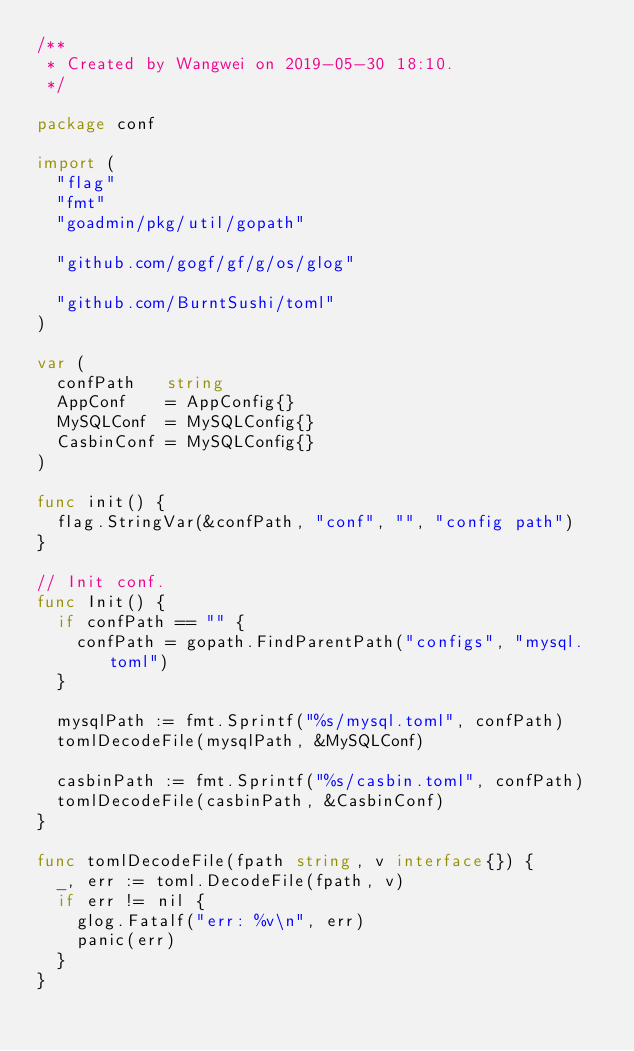<code> <loc_0><loc_0><loc_500><loc_500><_Go_>/**
 * Created by Wangwei on 2019-05-30 18:10.
 */

package conf

import (
	"flag"
	"fmt"
	"goadmin/pkg/util/gopath"

	"github.com/gogf/gf/g/os/glog"

	"github.com/BurntSushi/toml"
)

var (
	confPath   string
	AppConf    = AppConfig{}
	MySQLConf  = MySQLConfig{}
	CasbinConf = MySQLConfig{}
)

func init() {
	flag.StringVar(&confPath, "conf", "", "config path")
}

// Init conf.
func Init() {
	if confPath == "" {
		confPath = gopath.FindParentPath("configs", "mysql.toml")
	}

	mysqlPath := fmt.Sprintf("%s/mysql.toml", confPath)
	tomlDecodeFile(mysqlPath, &MySQLConf)

	casbinPath := fmt.Sprintf("%s/casbin.toml", confPath)
	tomlDecodeFile(casbinPath, &CasbinConf)
}

func tomlDecodeFile(fpath string, v interface{}) {
	_, err := toml.DecodeFile(fpath, v)
	if err != nil {
		glog.Fatalf("err: %v\n", err)
		panic(err)
	}
}
</code> 